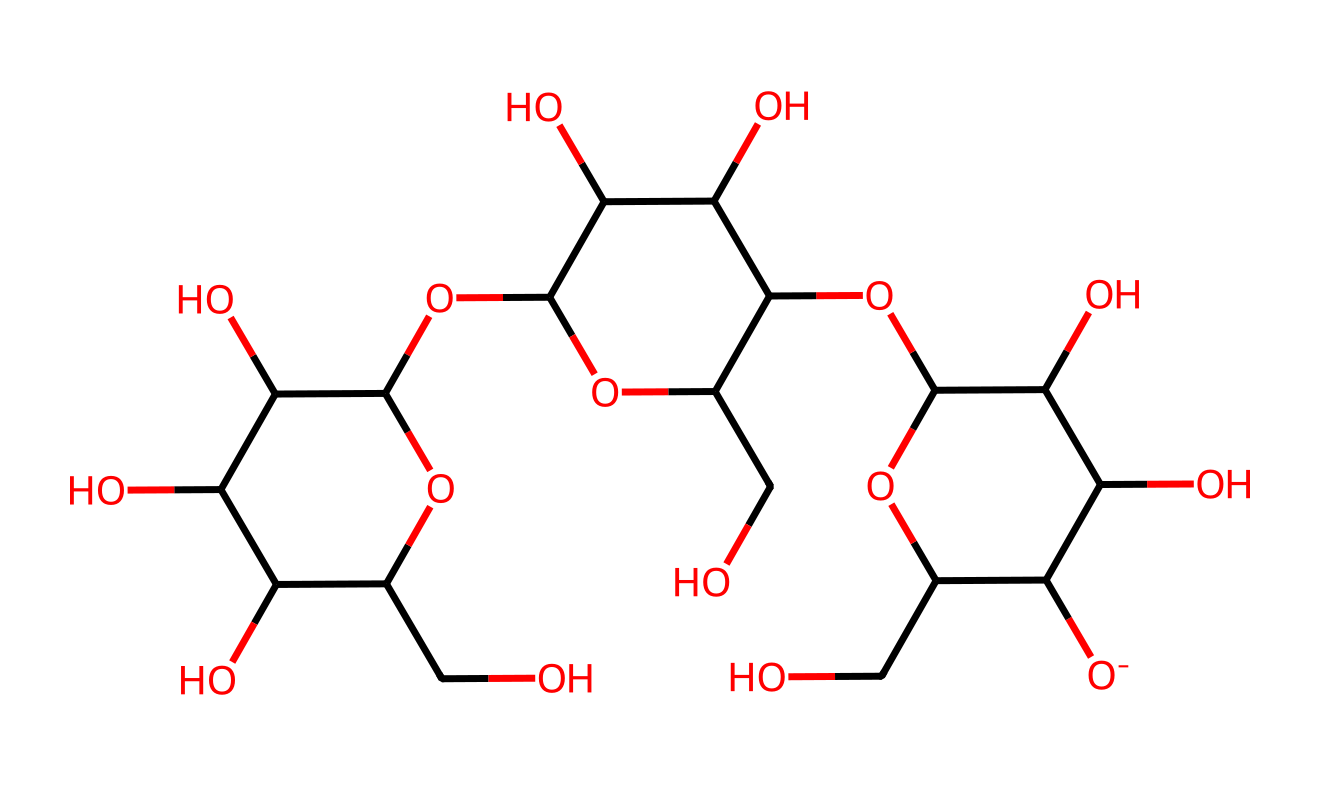What is the primary function of cellulose in paper? Cellulose provides structural support and strength to the paper, which is derived from its long-chain polymeric structure made of glucose units linked by β-1,4-glycosidic bonds.
Answer: structural support How many carbon atoms are present in the cellulose structure? By analyzing the SMILES notation, we can count the carbon atoms: there are a total of 12 carbon atoms represented in the structure of cellulose.
Answer: 12 What type of linkage connects the glucose units in cellulose? The linkage between glucose units is a β-1,4-glycosidic bond, which is a characteristic feature of cellulose.
Answer: β-1,4-glycosidic bond What is the molecular formula representation of cellulose? Based on the structure represented by the SMILES notation, the molecular formula of cellulose can be derived as C6H10O5 repeated, leading to a general formula of (C6H10O5)n where n is the degree of polymerization.
Answer: (C6H10O5)n How does the structure of cellulose contribute to its resistance to digestion by humans? The β-1,4-glycosidic linkages create a stable structure that is not easily broken down by human digestive enzymes, which predominantly target α-linkages found in starch.
Answer: stability of β-linkages 